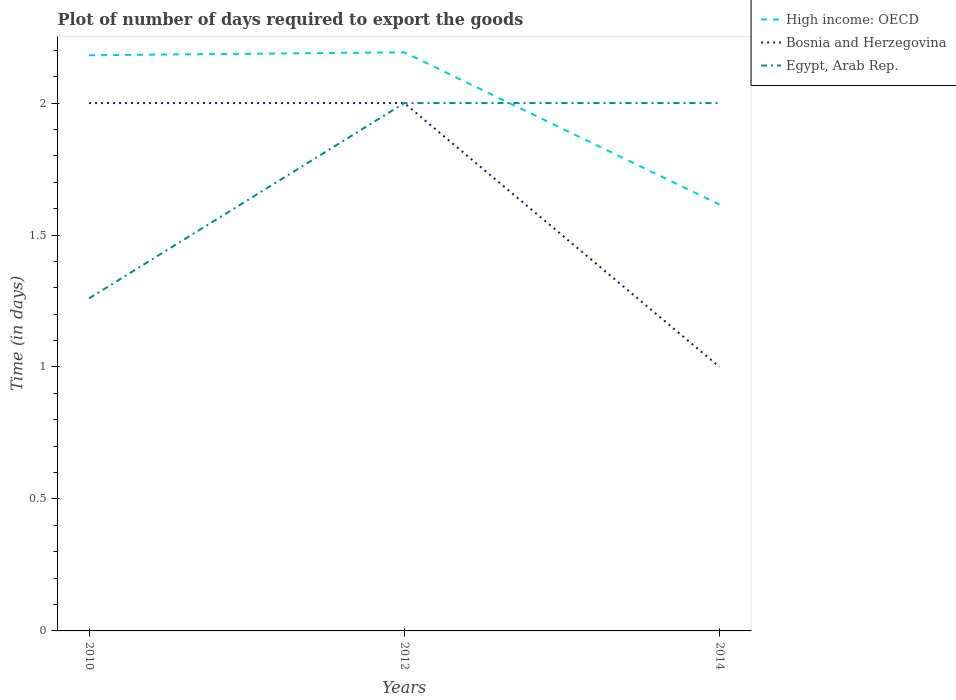How many different coloured lines are there?
Offer a very short reply. 3. Is the number of lines equal to the number of legend labels?
Your answer should be very brief. Yes. Across all years, what is the maximum time required to export goods in Bosnia and Herzegovina?
Provide a short and direct response. 1. In which year was the time required to export goods in Egypt, Arab Rep. maximum?
Provide a succinct answer. 2010. What is the total time required to export goods in High income: OECD in the graph?
Give a very brief answer. 0.58. What is the difference between the highest and the second highest time required to export goods in Egypt, Arab Rep.?
Make the answer very short. 0.74. Is the time required to export goods in High income: OECD strictly greater than the time required to export goods in Bosnia and Herzegovina over the years?
Your answer should be very brief. No. How many lines are there?
Make the answer very short. 3. What is the difference between two consecutive major ticks on the Y-axis?
Offer a terse response. 0.5. Does the graph contain grids?
Your answer should be compact. No. How many legend labels are there?
Your answer should be compact. 3. How are the legend labels stacked?
Provide a succinct answer. Vertical. What is the title of the graph?
Offer a very short reply. Plot of number of days required to export the goods. What is the label or title of the X-axis?
Offer a very short reply. Years. What is the label or title of the Y-axis?
Your answer should be very brief. Time (in days). What is the Time (in days) of High income: OECD in 2010?
Your answer should be very brief. 2.18. What is the Time (in days) in Bosnia and Herzegovina in 2010?
Make the answer very short. 2. What is the Time (in days) in Egypt, Arab Rep. in 2010?
Your response must be concise. 1.26. What is the Time (in days) of High income: OECD in 2012?
Your answer should be compact. 2.19. What is the Time (in days) in Egypt, Arab Rep. in 2012?
Ensure brevity in your answer.  2. What is the Time (in days) in High income: OECD in 2014?
Provide a short and direct response. 1.62. Across all years, what is the maximum Time (in days) of High income: OECD?
Ensure brevity in your answer.  2.19. Across all years, what is the maximum Time (in days) of Egypt, Arab Rep.?
Offer a very short reply. 2. Across all years, what is the minimum Time (in days) of High income: OECD?
Make the answer very short. 1.62. Across all years, what is the minimum Time (in days) in Egypt, Arab Rep.?
Your answer should be very brief. 1.26. What is the total Time (in days) in High income: OECD in the graph?
Make the answer very short. 5.99. What is the total Time (in days) of Bosnia and Herzegovina in the graph?
Make the answer very short. 5. What is the total Time (in days) in Egypt, Arab Rep. in the graph?
Offer a very short reply. 5.26. What is the difference between the Time (in days) in High income: OECD in 2010 and that in 2012?
Provide a short and direct response. -0.01. What is the difference between the Time (in days) in Bosnia and Herzegovina in 2010 and that in 2012?
Offer a very short reply. 0. What is the difference between the Time (in days) in Egypt, Arab Rep. in 2010 and that in 2012?
Give a very brief answer. -0.74. What is the difference between the Time (in days) in High income: OECD in 2010 and that in 2014?
Your response must be concise. 0.57. What is the difference between the Time (in days) in Bosnia and Herzegovina in 2010 and that in 2014?
Keep it short and to the point. 1. What is the difference between the Time (in days) in Egypt, Arab Rep. in 2010 and that in 2014?
Your answer should be compact. -0.74. What is the difference between the Time (in days) in High income: OECD in 2012 and that in 2014?
Give a very brief answer. 0.58. What is the difference between the Time (in days) in Bosnia and Herzegovina in 2012 and that in 2014?
Make the answer very short. 1. What is the difference between the Time (in days) of High income: OECD in 2010 and the Time (in days) of Bosnia and Herzegovina in 2012?
Offer a terse response. 0.18. What is the difference between the Time (in days) of High income: OECD in 2010 and the Time (in days) of Egypt, Arab Rep. in 2012?
Give a very brief answer. 0.18. What is the difference between the Time (in days) of High income: OECD in 2010 and the Time (in days) of Bosnia and Herzegovina in 2014?
Provide a short and direct response. 1.18. What is the difference between the Time (in days) in High income: OECD in 2010 and the Time (in days) in Egypt, Arab Rep. in 2014?
Your answer should be very brief. 0.18. What is the difference between the Time (in days) of Bosnia and Herzegovina in 2010 and the Time (in days) of Egypt, Arab Rep. in 2014?
Provide a short and direct response. 0. What is the difference between the Time (in days) in High income: OECD in 2012 and the Time (in days) in Bosnia and Herzegovina in 2014?
Keep it short and to the point. 1.19. What is the difference between the Time (in days) of High income: OECD in 2012 and the Time (in days) of Egypt, Arab Rep. in 2014?
Provide a short and direct response. 0.19. What is the average Time (in days) in High income: OECD per year?
Make the answer very short. 2. What is the average Time (in days) in Bosnia and Herzegovina per year?
Offer a terse response. 1.67. What is the average Time (in days) in Egypt, Arab Rep. per year?
Give a very brief answer. 1.75. In the year 2010, what is the difference between the Time (in days) in High income: OECD and Time (in days) in Bosnia and Herzegovina?
Make the answer very short. 0.18. In the year 2010, what is the difference between the Time (in days) in High income: OECD and Time (in days) in Egypt, Arab Rep.?
Keep it short and to the point. 0.92. In the year 2010, what is the difference between the Time (in days) of Bosnia and Herzegovina and Time (in days) of Egypt, Arab Rep.?
Provide a succinct answer. 0.74. In the year 2012, what is the difference between the Time (in days) of High income: OECD and Time (in days) of Bosnia and Herzegovina?
Offer a very short reply. 0.19. In the year 2012, what is the difference between the Time (in days) in High income: OECD and Time (in days) in Egypt, Arab Rep.?
Provide a short and direct response. 0.19. In the year 2014, what is the difference between the Time (in days) in High income: OECD and Time (in days) in Bosnia and Herzegovina?
Give a very brief answer. 0.62. In the year 2014, what is the difference between the Time (in days) of High income: OECD and Time (in days) of Egypt, Arab Rep.?
Give a very brief answer. -0.38. In the year 2014, what is the difference between the Time (in days) of Bosnia and Herzegovina and Time (in days) of Egypt, Arab Rep.?
Your answer should be very brief. -1. What is the ratio of the Time (in days) of Bosnia and Herzegovina in 2010 to that in 2012?
Provide a succinct answer. 1. What is the ratio of the Time (in days) in Egypt, Arab Rep. in 2010 to that in 2012?
Your answer should be compact. 0.63. What is the ratio of the Time (in days) in High income: OECD in 2010 to that in 2014?
Give a very brief answer. 1.35. What is the ratio of the Time (in days) in Egypt, Arab Rep. in 2010 to that in 2014?
Your response must be concise. 0.63. What is the ratio of the Time (in days) in High income: OECD in 2012 to that in 2014?
Offer a very short reply. 1.36. What is the ratio of the Time (in days) in Egypt, Arab Rep. in 2012 to that in 2014?
Provide a short and direct response. 1. What is the difference between the highest and the second highest Time (in days) in High income: OECD?
Offer a terse response. 0.01. What is the difference between the highest and the second highest Time (in days) in Bosnia and Herzegovina?
Offer a terse response. 0. What is the difference between the highest and the second highest Time (in days) in Egypt, Arab Rep.?
Your answer should be compact. 0. What is the difference between the highest and the lowest Time (in days) of High income: OECD?
Your response must be concise. 0.58. What is the difference between the highest and the lowest Time (in days) of Bosnia and Herzegovina?
Your answer should be compact. 1. What is the difference between the highest and the lowest Time (in days) of Egypt, Arab Rep.?
Keep it short and to the point. 0.74. 